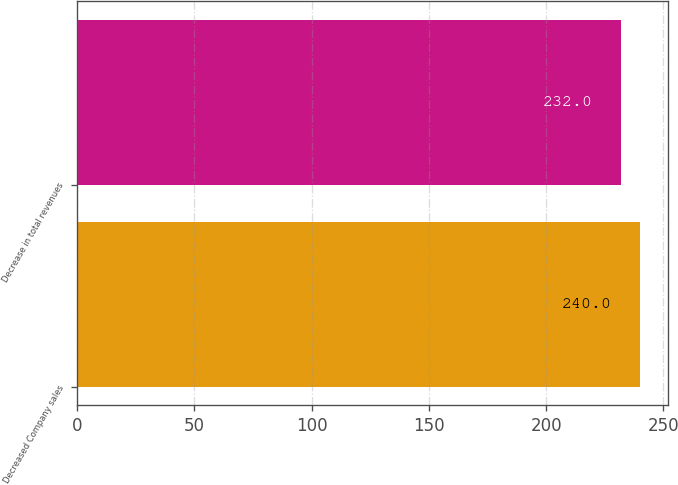<chart> <loc_0><loc_0><loc_500><loc_500><bar_chart><fcel>Decreased Company sales<fcel>Decrease in total revenues<nl><fcel>240<fcel>232<nl></chart> 